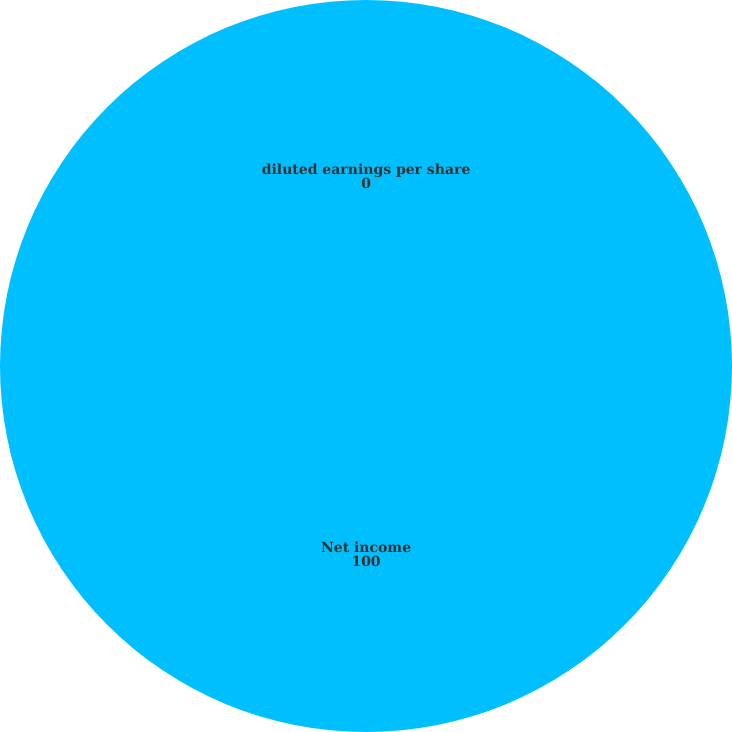<chart> <loc_0><loc_0><loc_500><loc_500><pie_chart><fcel>Net income<fcel>diluted earnings per share<nl><fcel>100.0%<fcel>0.0%<nl></chart> 